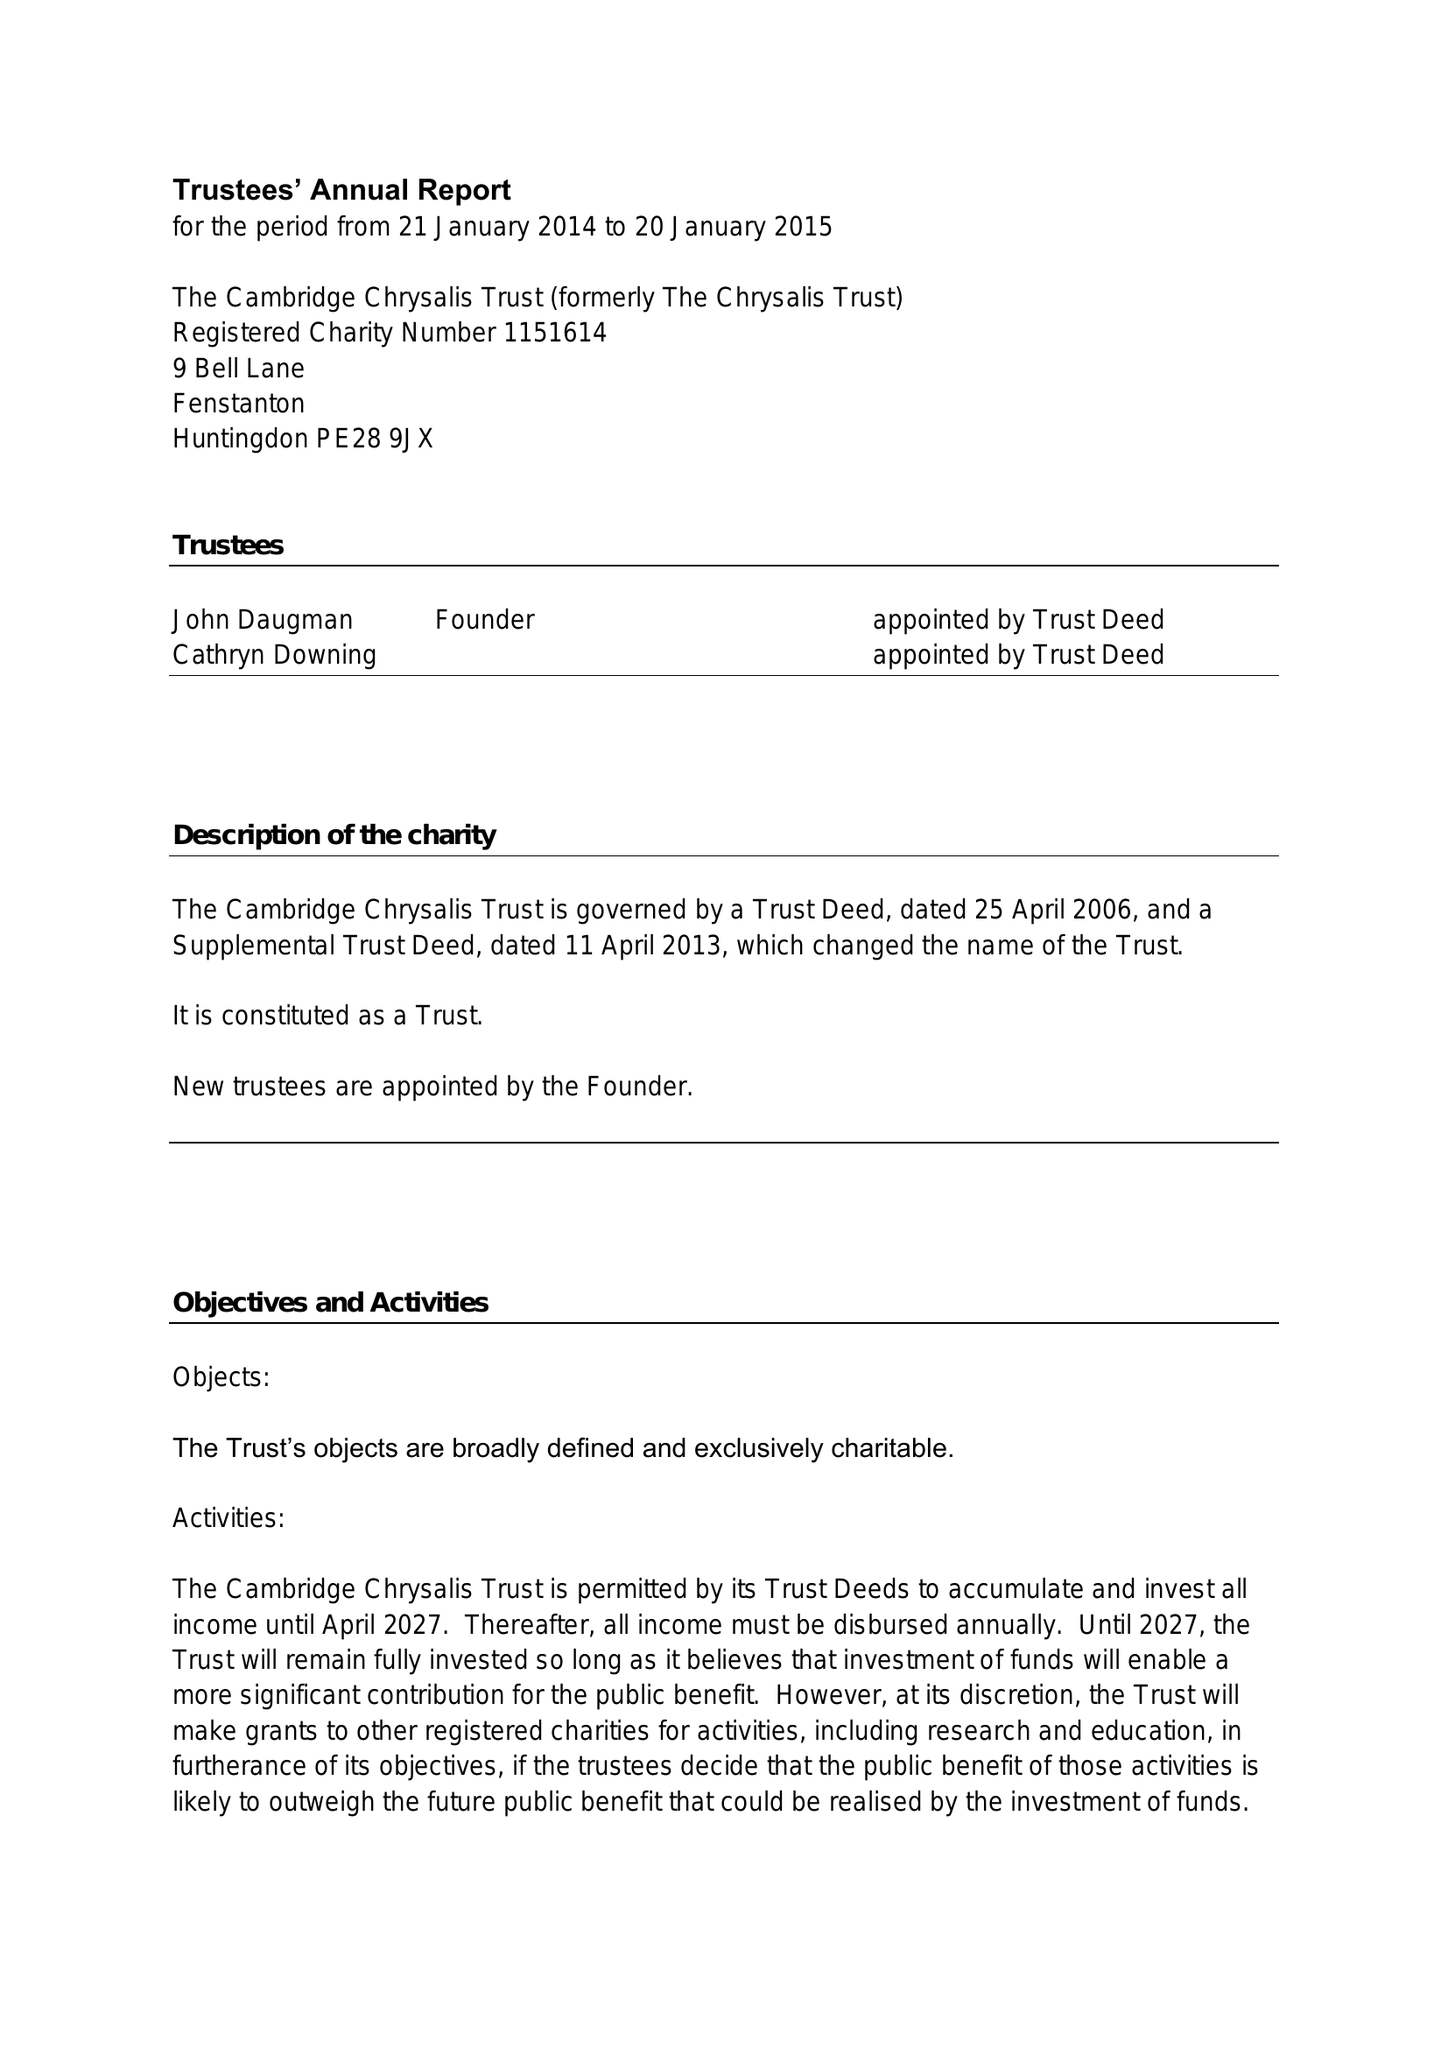What is the value for the address__post_town?
Answer the question using a single word or phrase. HUNTINGDON 